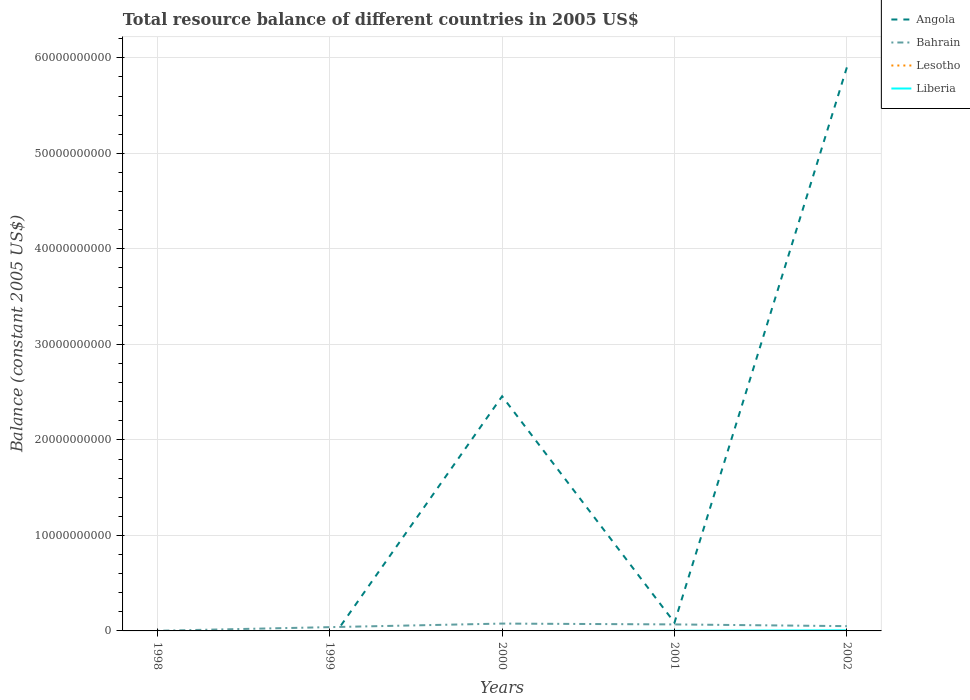Does the line corresponding to Angola intersect with the line corresponding to Bahrain?
Your answer should be compact. Yes. Is the number of lines equal to the number of legend labels?
Make the answer very short. No. What is the total total resource balance in Bahrain in the graph?
Offer a very short reply. -7.52e+08. What is the difference between the highest and the second highest total resource balance in Bahrain?
Ensure brevity in your answer.  7.52e+08. Is the total resource balance in Bahrain strictly greater than the total resource balance in Liberia over the years?
Your response must be concise. No. What is the difference between two consecutive major ticks on the Y-axis?
Provide a succinct answer. 1.00e+1. Does the graph contain any zero values?
Keep it short and to the point. Yes. Where does the legend appear in the graph?
Give a very brief answer. Top right. What is the title of the graph?
Offer a very short reply. Total resource balance of different countries in 2005 US$. Does "Moldova" appear as one of the legend labels in the graph?
Offer a terse response. No. What is the label or title of the Y-axis?
Provide a short and direct response. Balance (constant 2005 US$). What is the Balance (constant 2005 US$) in Angola in 1998?
Ensure brevity in your answer.  0. What is the Balance (constant 2005 US$) in Bahrain in 1998?
Offer a very short reply. 1.67e+07. What is the Balance (constant 2005 US$) of Bahrain in 1999?
Provide a short and direct response. 3.96e+08. What is the Balance (constant 2005 US$) in Angola in 2000?
Your response must be concise. 2.46e+1. What is the Balance (constant 2005 US$) in Bahrain in 2000?
Your answer should be compact. 7.68e+08. What is the Balance (constant 2005 US$) of Angola in 2001?
Give a very brief answer. 8.72e+08. What is the Balance (constant 2005 US$) of Bahrain in 2001?
Provide a succinct answer. 6.82e+08. What is the Balance (constant 2005 US$) of Lesotho in 2001?
Offer a very short reply. 0. What is the Balance (constant 2005 US$) of Liberia in 2001?
Give a very brief answer. 1.33e+07. What is the Balance (constant 2005 US$) of Angola in 2002?
Ensure brevity in your answer.  5.90e+1. What is the Balance (constant 2005 US$) in Bahrain in 2002?
Give a very brief answer. 5.01e+08. What is the Balance (constant 2005 US$) of Liberia in 2002?
Your answer should be compact. 6.29e+07. Across all years, what is the maximum Balance (constant 2005 US$) in Angola?
Provide a short and direct response. 5.90e+1. Across all years, what is the maximum Balance (constant 2005 US$) of Bahrain?
Ensure brevity in your answer.  7.68e+08. Across all years, what is the maximum Balance (constant 2005 US$) in Liberia?
Ensure brevity in your answer.  6.29e+07. Across all years, what is the minimum Balance (constant 2005 US$) of Angola?
Offer a very short reply. 0. Across all years, what is the minimum Balance (constant 2005 US$) of Bahrain?
Provide a succinct answer. 1.67e+07. Across all years, what is the minimum Balance (constant 2005 US$) in Liberia?
Provide a succinct answer. 0. What is the total Balance (constant 2005 US$) of Angola in the graph?
Provide a short and direct response. 8.44e+1. What is the total Balance (constant 2005 US$) in Bahrain in the graph?
Offer a terse response. 2.36e+09. What is the total Balance (constant 2005 US$) in Liberia in the graph?
Provide a succinct answer. 7.62e+07. What is the difference between the Balance (constant 2005 US$) of Bahrain in 1998 and that in 1999?
Offer a very short reply. -3.79e+08. What is the difference between the Balance (constant 2005 US$) of Bahrain in 1998 and that in 2000?
Your answer should be compact. -7.52e+08. What is the difference between the Balance (constant 2005 US$) in Bahrain in 1998 and that in 2001?
Ensure brevity in your answer.  -6.65e+08. What is the difference between the Balance (constant 2005 US$) in Bahrain in 1998 and that in 2002?
Your response must be concise. -4.84e+08. What is the difference between the Balance (constant 2005 US$) of Bahrain in 1999 and that in 2000?
Give a very brief answer. -3.73e+08. What is the difference between the Balance (constant 2005 US$) in Bahrain in 1999 and that in 2001?
Your answer should be very brief. -2.86e+08. What is the difference between the Balance (constant 2005 US$) of Bahrain in 1999 and that in 2002?
Give a very brief answer. -1.05e+08. What is the difference between the Balance (constant 2005 US$) of Angola in 2000 and that in 2001?
Offer a terse response. 2.37e+1. What is the difference between the Balance (constant 2005 US$) in Bahrain in 2000 and that in 2001?
Provide a succinct answer. 8.69e+07. What is the difference between the Balance (constant 2005 US$) in Angola in 2000 and that in 2002?
Give a very brief answer. -3.44e+1. What is the difference between the Balance (constant 2005 US$) in Bahrain in 2000 and that in 2002?
Provide a succinct answer. 2.68e+08. What is the difference between the Balance (constant 2005 US$) of Angola in 2001 and that in 2002?
Ensure brevity in your answer.  -5.81e+1. What is the difference between the Balance (constant 2005 US$) of Bahrain in 2001 and that in 2002?
Your response must be concise. 1.81e+08. What is the difference between the Balance (constant 2005 US$) of Liberia in 2001 and that in 2002?
Your answer should be compact. -4.96e+07. What is the difference between the Balance (constant 2005 US$) in Bahrain in 1998 and the Balance (constant 2005 US$) in Liberia in 2001?
Provide a succinct answer. 3.39e+06. What is the difference between the Balance (constant 2005 US$) of Bahrain in 1998 and the Balance (constant 2005 US$) of Liberia in 2002?
Your answer should be compact. -4.62e+07. What is the difference between the Balance (constant 2005 US$) of Bahrain in 1999 and the Balance (constant 2005 US$) of Liberia in 2001?
Ensure brevity in your answer.  3.83e+08. What is the difference between the Balance (constant 2005 US$) of Bahrain in 1999 and the Balance (constant 2005 US$) of Liberia in 2002?
Offer a very short reply. 3.33e+08. What is the difference between the Balance (constant 2005 US$) of Angola in 2000 and the Balance (constant 2005 US$) of Bahrain in 2001?
Ensure brevity in your answer.  2.39e+1. What is the difference between the Balance (constant 2005 US$) of Angola in 2000 and the Balance (constant 2005 US$) of Liberia in 2001?
Make the answer very short. 2.46e+1. What is the difference between the Balance (constant 2005 US$) of Bahrain in 2000 and the Balance (constant 2005 US$) of Liberia in 2001?
Provide a short and direct response. 7.55e+08. What is the difference between the Balance (constant 2005 US$) of Angola in 2000 and the Balance (constant 2005 US$) of Bahrain in 2002?
Ensure brevity in your answer.  2.41e+1. What is the difference between the Balance (constant 2005 US$) in Angola in 2000 and the Balance (constant 2005 US$) in Liberia in 2002?
Your answer should be compact. 2.45e+1. What is the difference between the Balance (constant 2005 US$) in Bahrain in 2000 and the Balance (constant 2005 US$) in Liberia in 2002?
Make the answer very short. 7.06e+08. What is the difference between the Balance (constant 2005 US$) of Angola in 2001 and the Balance (constant 2005 US$) of Bahrain in 2002?
Provide a succinct answer. 3.71e+08. What is the difference between the Balance (constant 2005 US$) in Angola in 2001 and the Balance (constant 2005 US$) in Liberia in 2002?
Offer a terse response. 8.09e+08. What is the difference between the Balance (constant 2005 US$) of Bahrain in 2001 and the Balance (constant 2005 US$) of Liberia in 2002?
Offer a terse response. 6.19e+08. What is the average Balance (constant 2005 US$) of Angola per year?
Provide a succinct answer. 1.69e+1. What is the average Balance (constant 2005 US$) in Bahrain per year?
Offer a terse response. 4.73e+08. What is the average Balance (constant 2005 US$) in Lesotho per year?
Offer a very short reply. 0. What is the average Balance (constant 2005 US$) of Liberia per year?
Your answer should be compact. 1.52e+07. In the year 2000, what is the difference between the Balance (constant 2005 US$) in Angola and Balance (constant 2005 US$) in Bahrain?
Give a very brief answer. 2.38e+1. In the year 2001, what is the difference between the Balance (constant 2005 US$) of Angola and Balance (constant 2005 US$) of Bahrain?
Your answer should be compact. 1.91e+08. In the year 2001, what is the difference between the Balance (constant 2005 US$) in Angola and Balance (constant 2005 US$) in Liberia?
Your response must be concise. 8.59e+08. In the year 2001, what is the difference between the Balance (constant 2005 US$) in Bahrain and Balance (constant 2005 US$) in Liberia?
Make the answer very short. 6.68e+08. In the year 2002, what is the difference between the Balance (constant 2005 US$) of Angola and Balance (constant 2005 US$) of Bahrain?
Keep it short and to the point. 5.85e+1. In the year 2002, what is the difference between the Balance (constant 2005 US$) in Angola and Balance (constant 2005 US$) in Liberia?
Offer a terse response. 5.89e+1. In the year 2002, what is the difference between the Balance (constant 2005 US$) in Bahrain and Balance (constant 2005 US$) in Liberia?
Offer a terse response. 4.38e+08. What is the ratio of the Balance (constant 2005 US$) of Bahrain in 1998 to that in 1999?
Your answer should be compact. 0.04. What is the ratio of the Balance (constant 2005 US$) in Bahrain in 1998 to that in 2000?
Provide a short and direct response. 0.02. What is the ratio of the Balance (constant 2005 US$) in Bahrain in 1998 to that in 2001?
Ensure brevity in your answer.  0.02. What is the ratio of the Balance (constant 2005 US$) in Bahrain in 1999 to that in 2000?
Your answer should be compact. 0.52. What is the ratio of the Balance (constant 2005 US$) of Bahrain in 1999 to that in 2001?
Your answer should be very brief. 0.58. What is the ratio of the Balance (constant 2005 US$) of Bahrain in 1999 to that in 2002?
Keep it short and to the point. 0.79. What is the ratio of the Balance (constant 2005 US$) in Angola in 2000 to that in 2001?
Provide a succinct answer. 28.17. What is the ratio of the Balance (constant 2005 US$) in Bahrain in 2000 to that in 2001?
Provide a short and direct response. 1.13. What is the ratio of the Balance (constant 2005 US$) in Angola in 2000 to that in 2002?
Ensure brevity in your answer.  0.42. What is the ratio of the Balance (constant 2005 US$) in Bahrain in 2000 to that in 2002?
Provide a succinct answer. 1.53. What is the ratio of the Balance (constant 2005 US$) of Angola in 2001 to that in 2002?
Your answer should be very brief. 0.01. What is the ratio of the Balance (constant 2005 US$) of Bahrain in 2001 to that in 2002?
Provide a succinct answer. 1.36. What is the ratio of the Balance (constant 2005 US$) of Liberia in 2001 to that in 2002?
Your answer should be compact. 0.21. What is the difference between the highest and the second highest Balance (constant 2005 US$) in Angola?
Give a very brief answer. 3.44e+1. What is the difference between the highest and the second highest Balance (constant 2005 US$) of Bahrain?
Keep it short and to the point. 8.69e+07. What is the difference between the highest and the lowest Balance (constant 2005 US$) in Angola?
Make the answer very short. 5.90e+1. What is the difference between the highest and the lowest Balance (constant 2005 US$) of Bahrain?
Offer a very short reply. 7.52e+08. What is the difference between the highest and the lowest Balance (constant 2005 US$) of Liberia?
Offer a very short reply. 6.29e+07. 